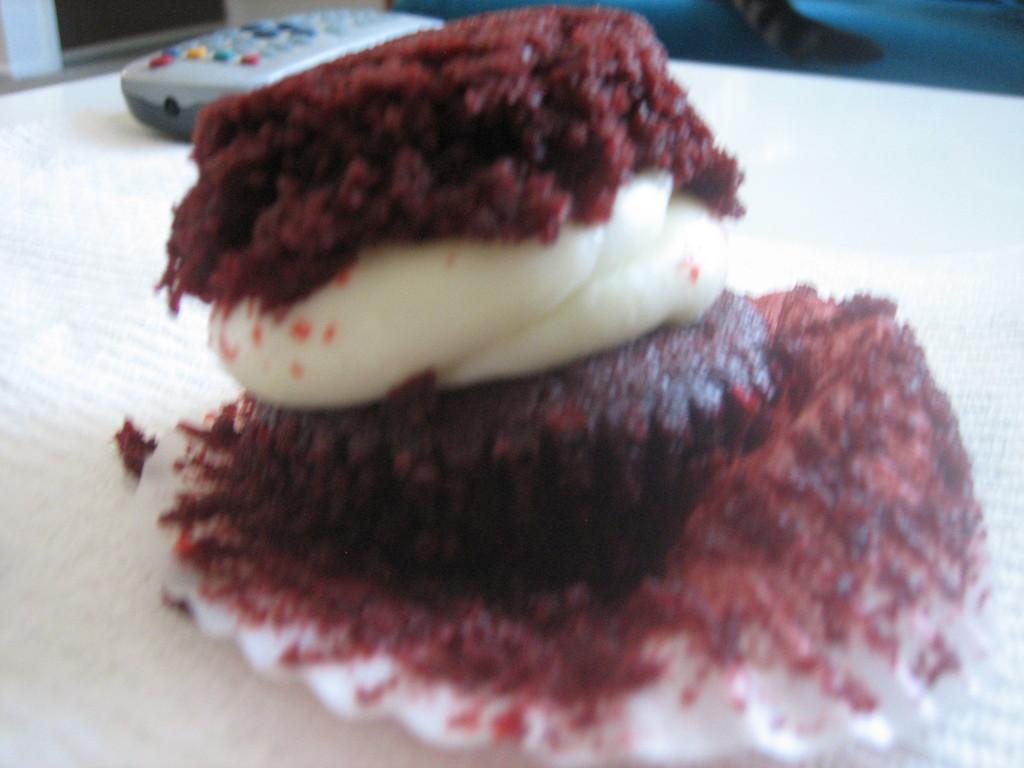Describe this image in one or two sentences. In this picture I can see food item on the surface. I can see the remote control. 